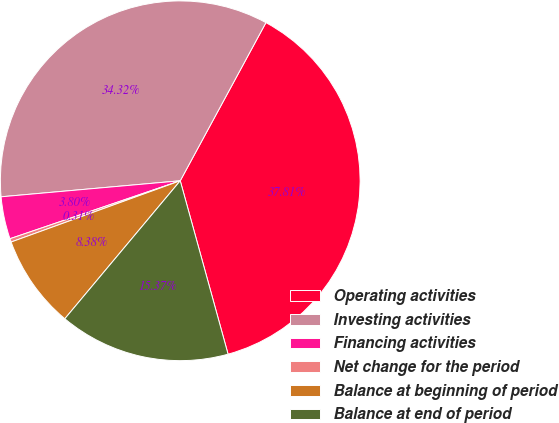Convert chart to OTSL. <chart><loc_0><loc_0><loc_500><loc_500><pie_chart><fcel>Operating activities<fcel>Investing activities<fcel>Financing activities<fcel>Net change for the period<fcel>Balance at beginning of period<fcel>Balance at end of period<nl><fcel>37.81%<fcel>34.32%<fcel>3.8%<fcel>0.31%<fcel>8.38%<fcel>15.37%<nl></chart> 